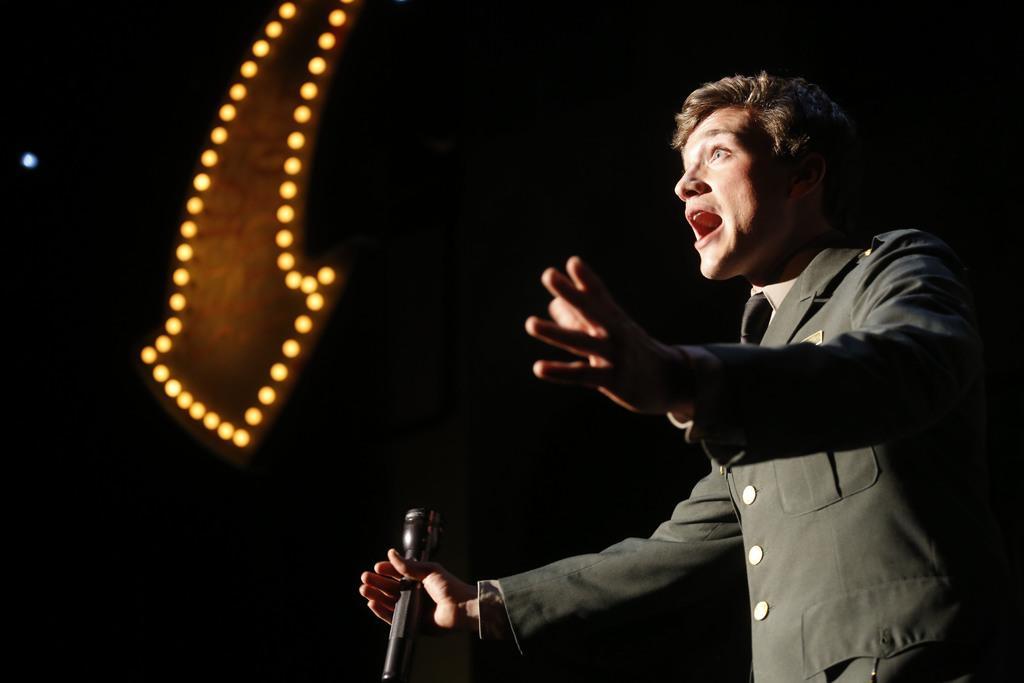In one or two sentences, can you explain what this image depicts? This image consists of a person. He is wearing a black jacket. He is holding a mic in his hand. There are lights on the left side. 